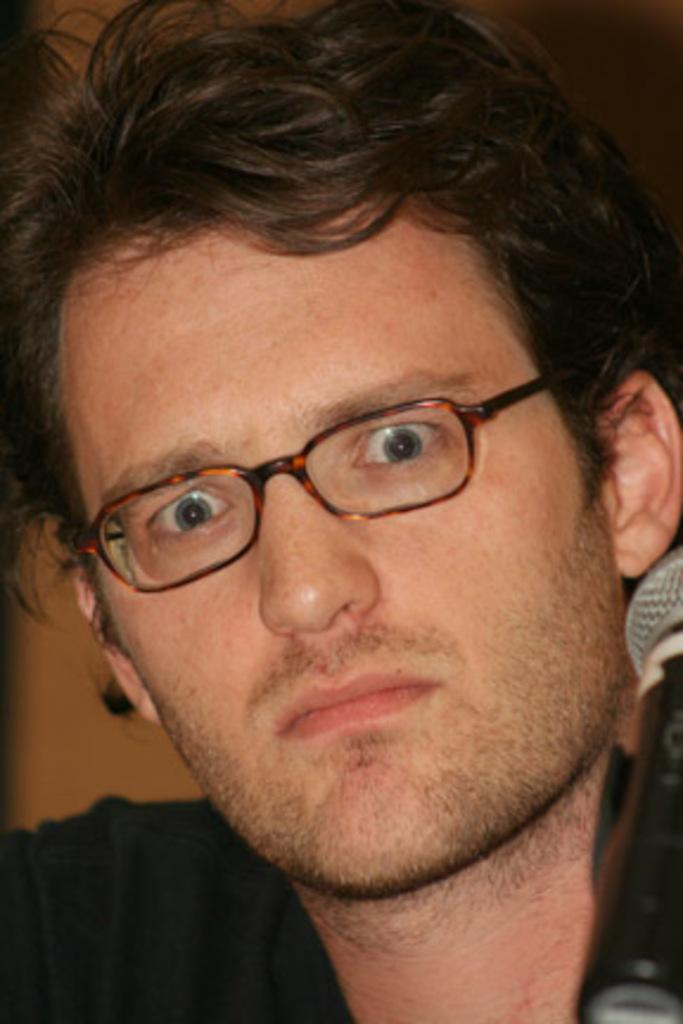What object is present in the image that is used for amplifying sound? There is a mic in the image that is used for amplifying sound. Who is in the image? There is a man in the image. What accessory is the man wearing in the image? The man is wearing spectacles in the image. What can be seen in the background of the image? There is a wall in the background of the image. What type of doll is sitting on the wall in the image? There is no doll present in the image; it only features a mic, a man, and a wall in the background. 